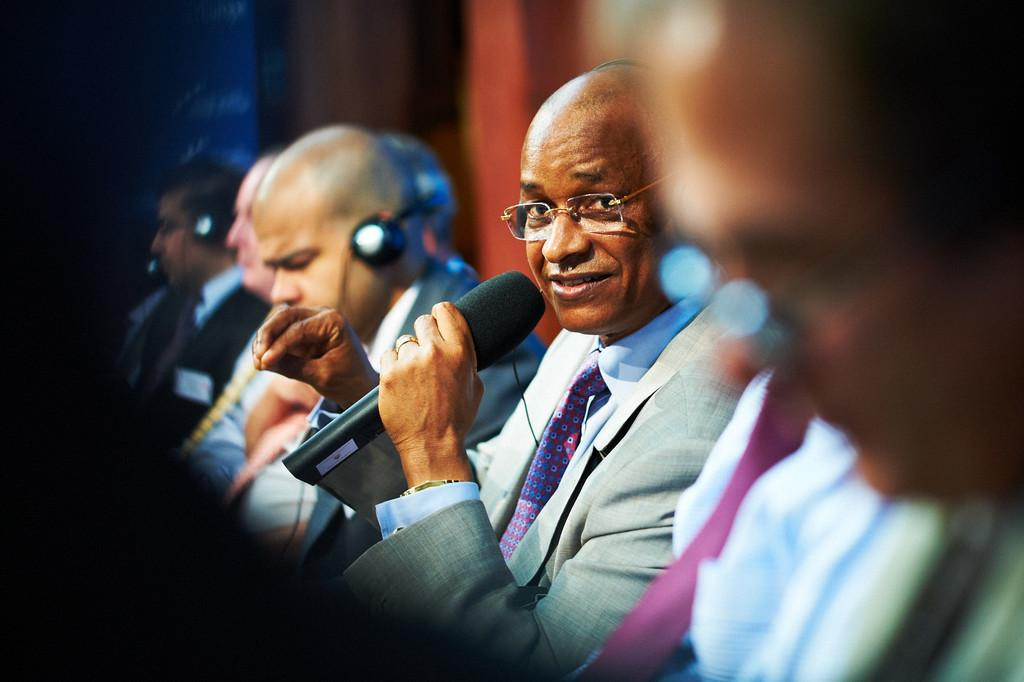How many people are in the image? There is a group of people in the image. What are the people in the image doing? The people are seated. Can you describe the man in the image? The man is holding a microphone. What is the man doing with the microphone? The man is speaking. What type of coat is the man wearing in the alley while solving the riddle? There is no coat, alley, or riddle present in the image. The man is holding a microphone and speaking, but there is no mention of a coat or an alley, nor is there any indication that a riddle is being solved. 